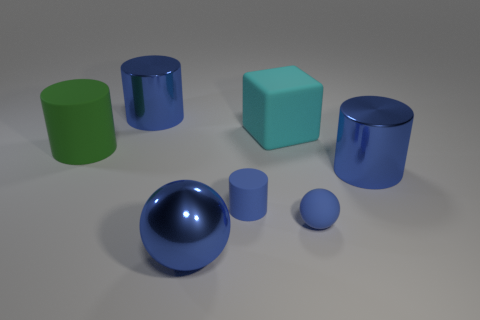Is the number of large shiny cylinders that are behind the large blue sphere greater than the number of big blue shiny cylinders to the left of the large green cylinder?
Your answer should be very brief. Yes. Is the size of the green object the same as the metallic ball?
Provide a short and direct response. Yes. There is a large object that is on the left side of the cylinder that is behind the green matte cylinder; what is its color?
Your answer should be very brief. Green. The big metal ball is what color?
Keep it short and to the point. Blue. Are there any cylinders of the same color as the block?
Your answer should be very brief. No. There is a small thing that is to the right of the small blue cylinder; is its color the same as the cube?
Make the answer very short. No. How many objects are either big metal cylinders behind the big green thing or tiny blue balls?
Keep it short and to the point. 2. There is a big cyan object; are there any rubber things left of it?
Ensure brevity in your answer.  Yes. What material is the small cylinder that is the same color as the metallic ball?
Your response must be concise. Rubber. Do the large cylinder right of the big cyan matte cube and the large sphere have the same material?
Your response must be concise. Yes. 